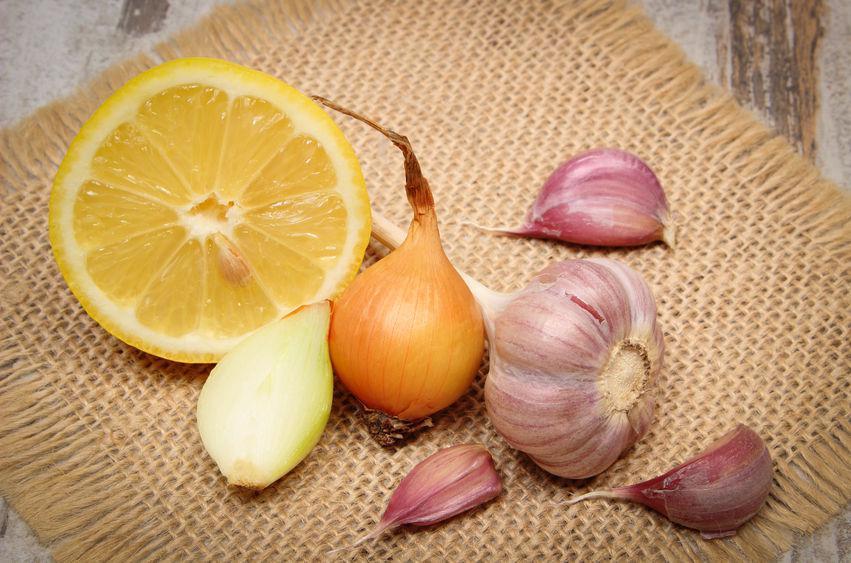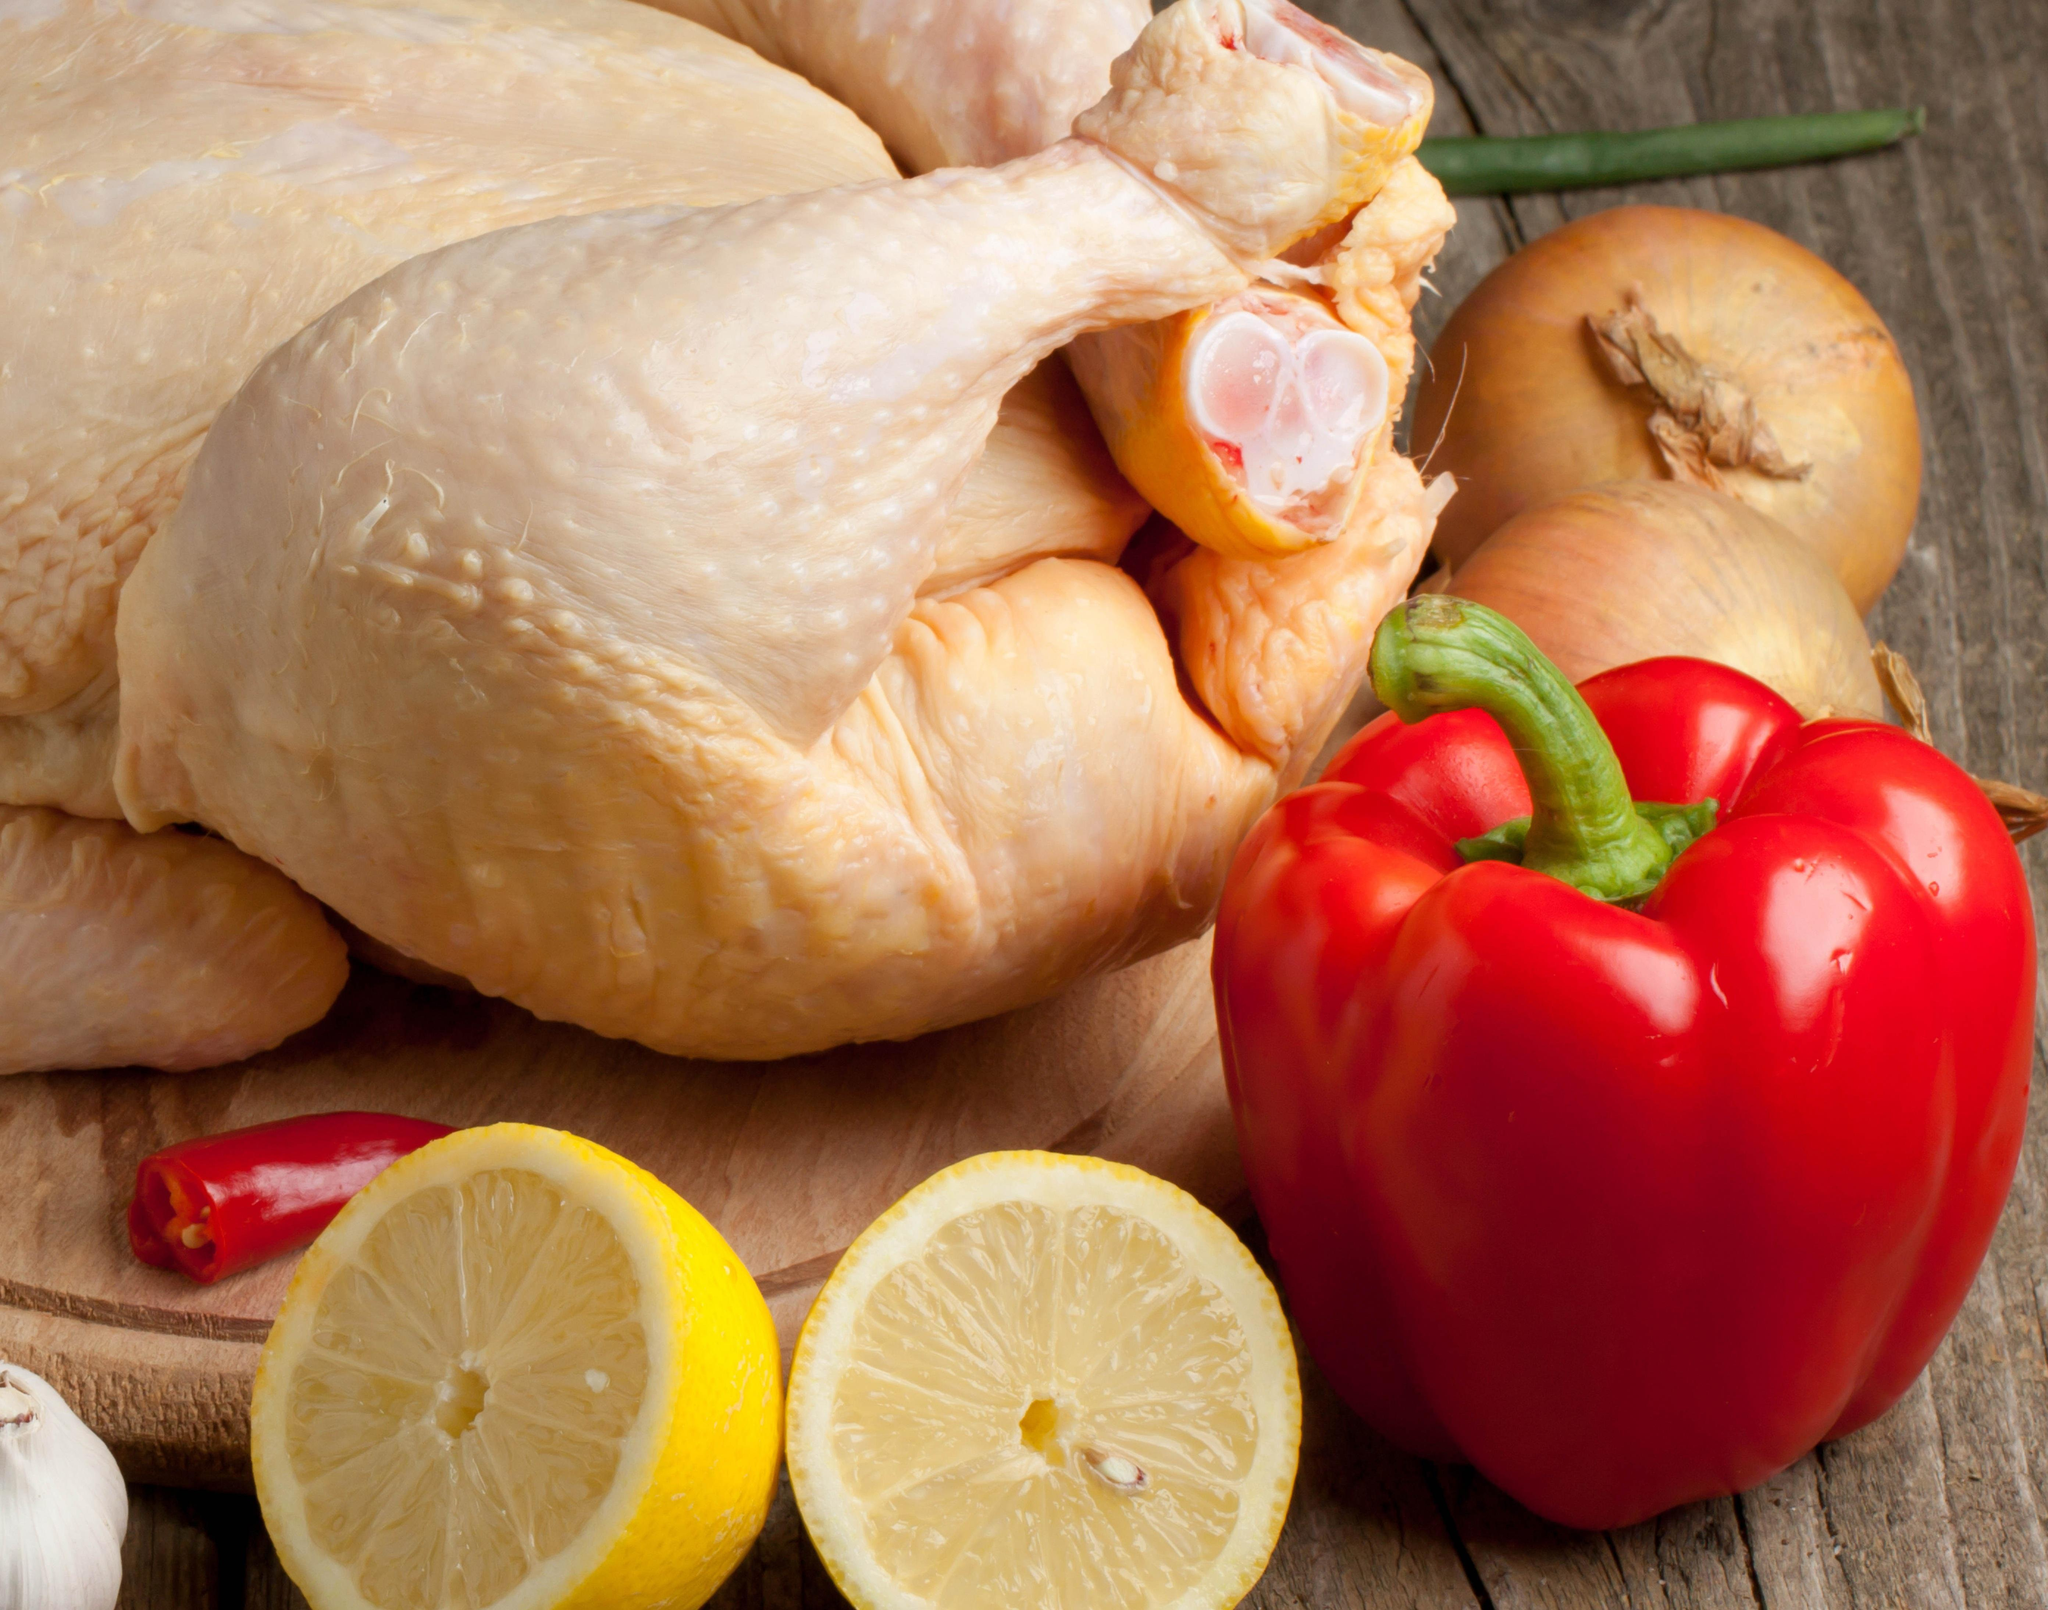The first image is the image on the left, the second image is the image on the right. For the images displayed, is the sentence "In one image, half a lemon, onions and some garlic are on a square mat." factually correct? Answer yes or no. Yes. 